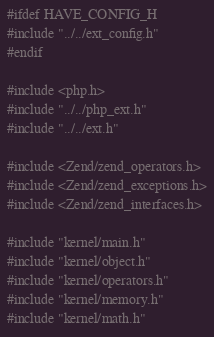<code> <loc_0><loc_0><loc_500><loc_500><_C_>
#ifdef HAVE_CONFIG_H
#include "../../ext_config.h"
#endif

#include <php.h>
#include "../../php_ext.h"
#include "../../ext.h"

#include <Zend/zend_operators.h>
#include <Zend/zend_exceptions.h>
#include <Zend/zend_interfaces.h>

#include "kernel/main.h"
#include "kernel/object.h"
#include "kernel/operators.h"
#include "kernel/memory.h"
#include "kernel/math.h"

</code> 